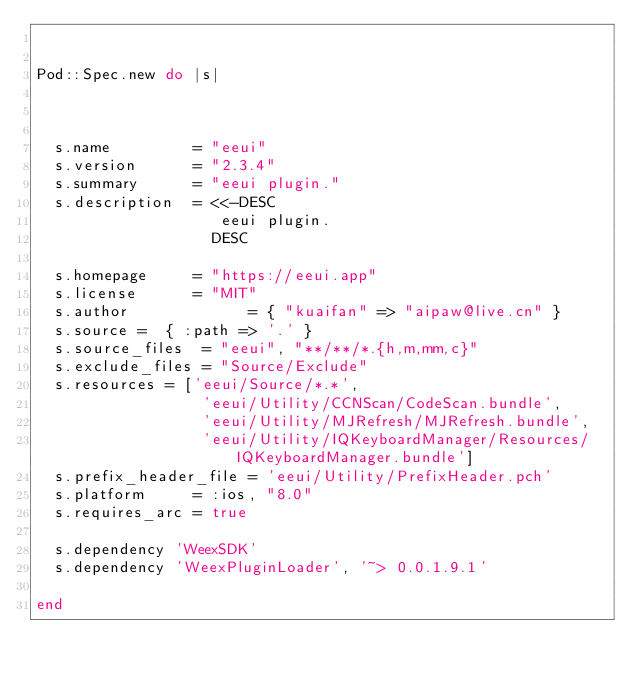Convert code to text. <code><loc_0><loc_0><loc_500><loc_500><_Ruby_>

Pod::Spec.new do |s|



  s.name         = "eeui"
  s.version      = "2.3.4"
  s.summary      = "eeui plugin."
  s.description  = <<-DESC
                    eeui plugin.
                   DESC

  s.homepage     = "https://eeui.app"
  s.license      = "MIT"
  s.author             = { "kuaifan" => "aipaw@live.cn" }
  s.source =  { :path => '.' }
  s.source_files  = "eeui", "**/**/*.{h,m,mm,c}"
  s.exclude_files = "Source/Exclude"
  s.resources = ['eeui/Source/*.*',
                  'eeui/Utility/CCNScan/CodeScan.bundle',
                  'eeui/Utility/MJRefresh/MJRefresh.bundle',
                  'eeui/Utility/IQKeyboardManager/Resources/IQKeyboardManager.bundle']
  s.prefix_header_file = 'eeui/Utility/PrefixHeader.pch'
  s.platform     = :ios, "8.0"
  s.requires_arc = true

  s.dependency 'WeexSDK'
  s.dependency 'WeexPluginLoader', '~> 0.0.1.9.1'

end
</code> 